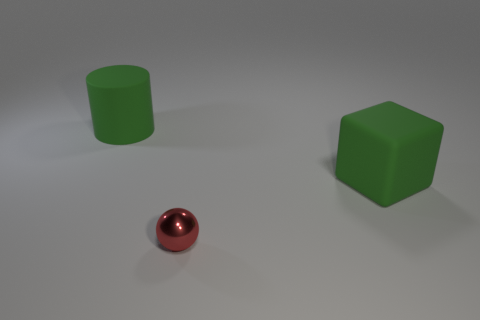Add 2 red matte blocks. How many objects exist? 5 Subtract all cylinders. How many objects are left? 2 Subtract 0 yellow cubes. How many objects are left? 3 Subtract all small metal cylinders. Subtract all tiny red shiny objects. How many objects are left? 2 Add 3 large green rubber things. How many large green rubber things are left? 5 Add 1 big green objects. How many big green objects exist? 3 